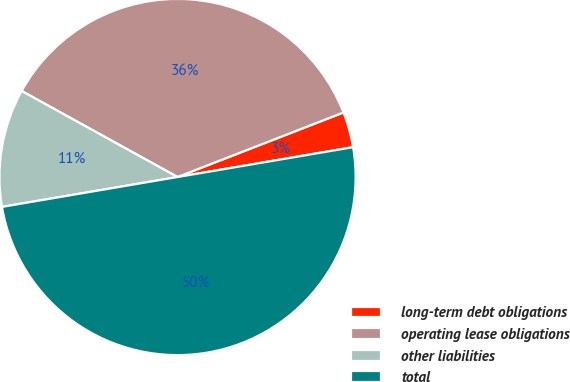Convert chart to OTSL. <chart><loc_0><loc_0><loc_500><loc_500><pie_chart><fcel>long-term debt obligations<fcel>operating lease obligations<fcel>other liabilities<fcel>total<nl><fcel>3.22%<fcel>36.07%<fcel>10.71%<fcel>50.0%<nl></chart> 